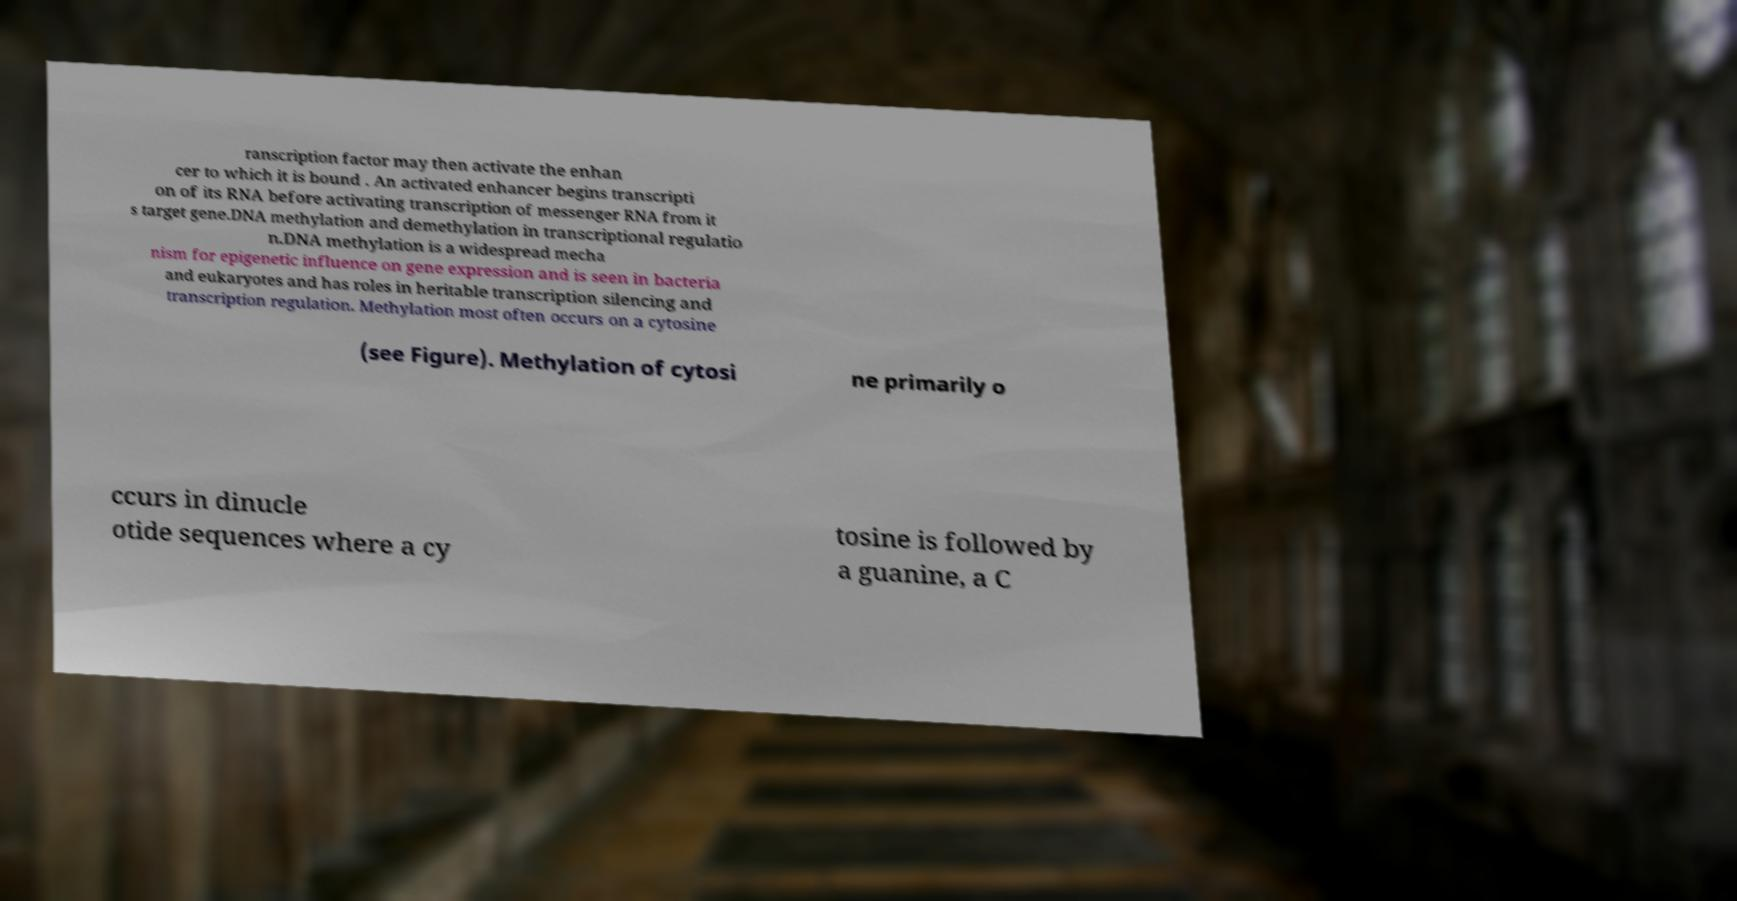Can you accurately transcribe the text from the provided image for me? ranscription factor may then activate the enhan cer to which it is bound . An activated enhancer begins transcripti on of its RNA before activating transcription of messenger RNA from it s target gene.DNA methylation and demethylation in transcriptional regulatio n.DNA methylation is a widespread mecha nism for epigenetic influence on gene expression and is seen in bacteria and eukaryotes and has roles in heritable transcription silencing and transcription regulation. Methylation most often occurs on a cytosine (see Figure). Methylation of cytosi ne primarily o ccurs in dinucle otide sequences where a cy tosine is followed by a guanine, a C 